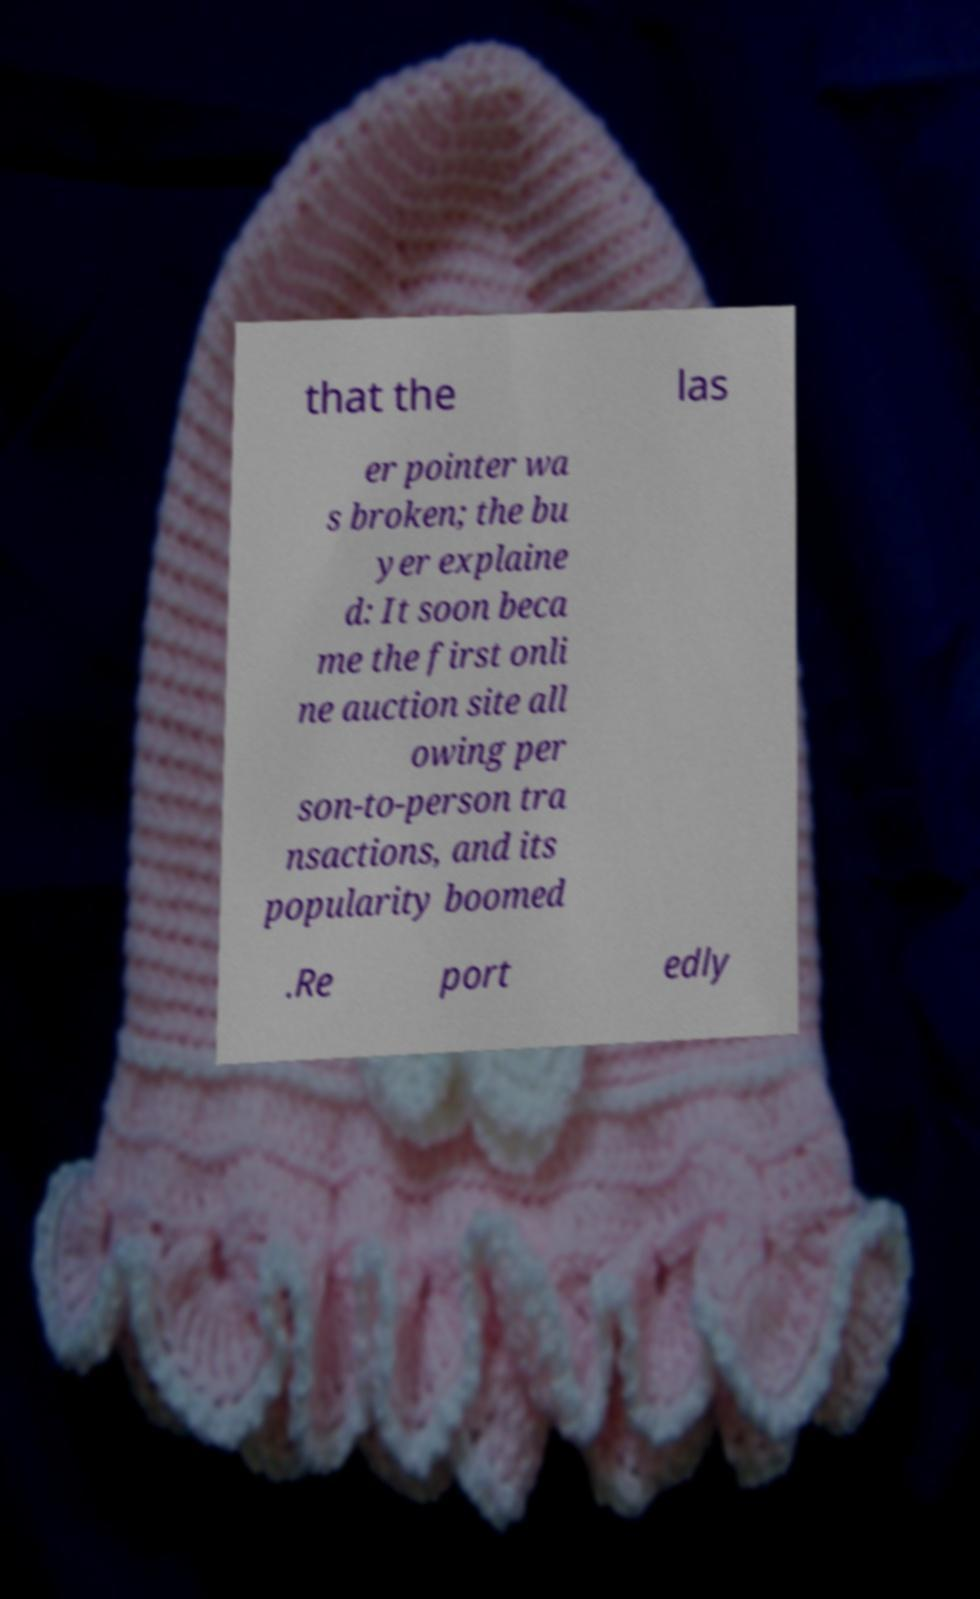Please read and relay the text visible in this image. What does it say? that the las er pointer wa s broken; the bu yer explaine d: It soon beca me the first onli ne auction site all owing per son-to-person tra nsactions, and its popularity boomed .Re port edly 